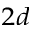Convert formula to latex. <formula><loc_0><loc_0><loc_500><loc_500>_ { 2 d }</formula> 